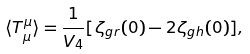Convert formula to latex. <formula><loc_0><loc_0><loc_500><loc_500>\langle T _ { \mu } ^ { \mu } \rangle = \frac { 1 } { V _ { 4 } } [ \zeta _ { g r } ( 0 ) - 2 \zeta _ { g h } ( 0 ) ] ,</formula> 